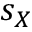<formula> <loc_0><loc_0><loc_500><loc_500>s _ { X }</formula> 